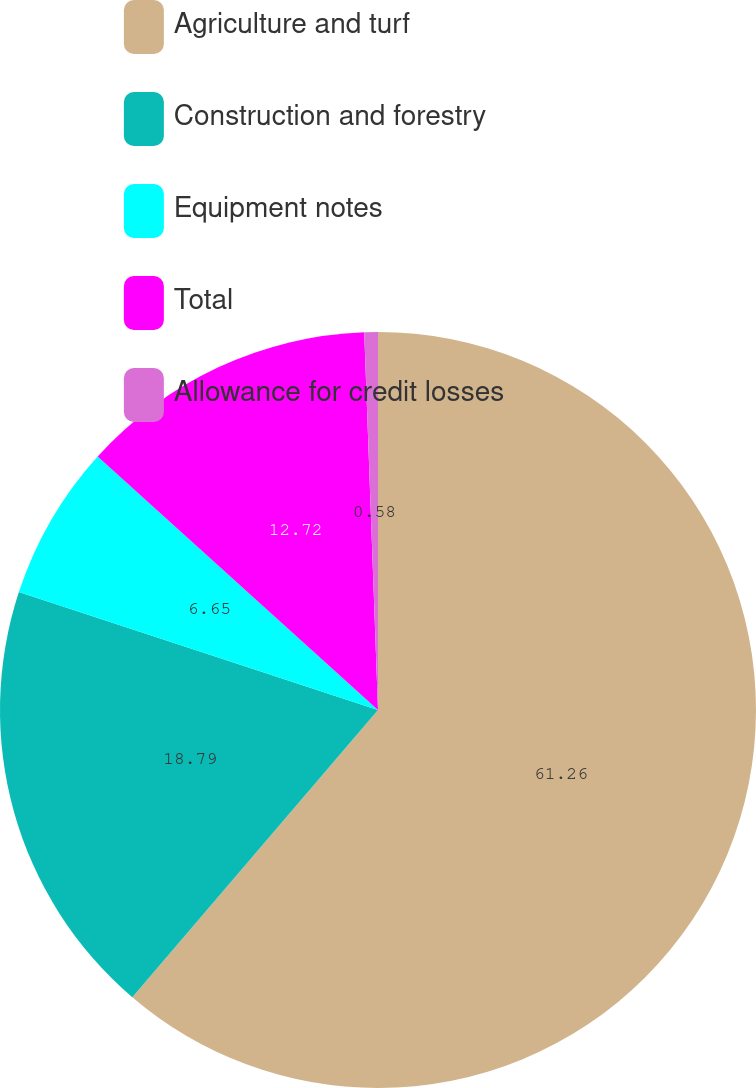Convert chart to OTSL. <chart><loc_0><loc_0><loc_500><loc_500><pie_chart><fcel>Agriculture and turf<fcel>Construction and forestry<fcel>Equipment notes<fcel>Total<fcel>Allowance for credit losses<nl><fcel>61.26%<fcel>18.79%<fcel>6.65%<fcel>12.72%<fcel>0.58%<nl></chart> 